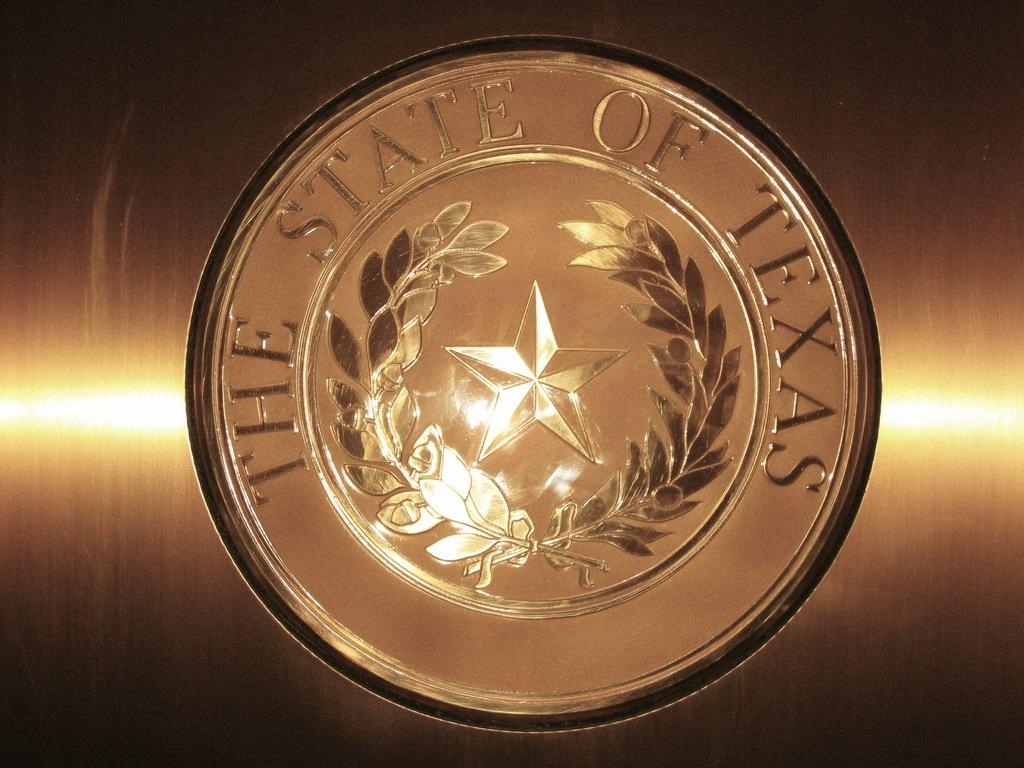What is featured in the image that represents a brand or company? There is a logo in the image that represents a brand or company. What else can be seen in the image besides the logo? There is text in the image. How many stars can be seen in the image? There are no stars present in the image. What type of coast is visible in the image? There is no coast visible in the image. 